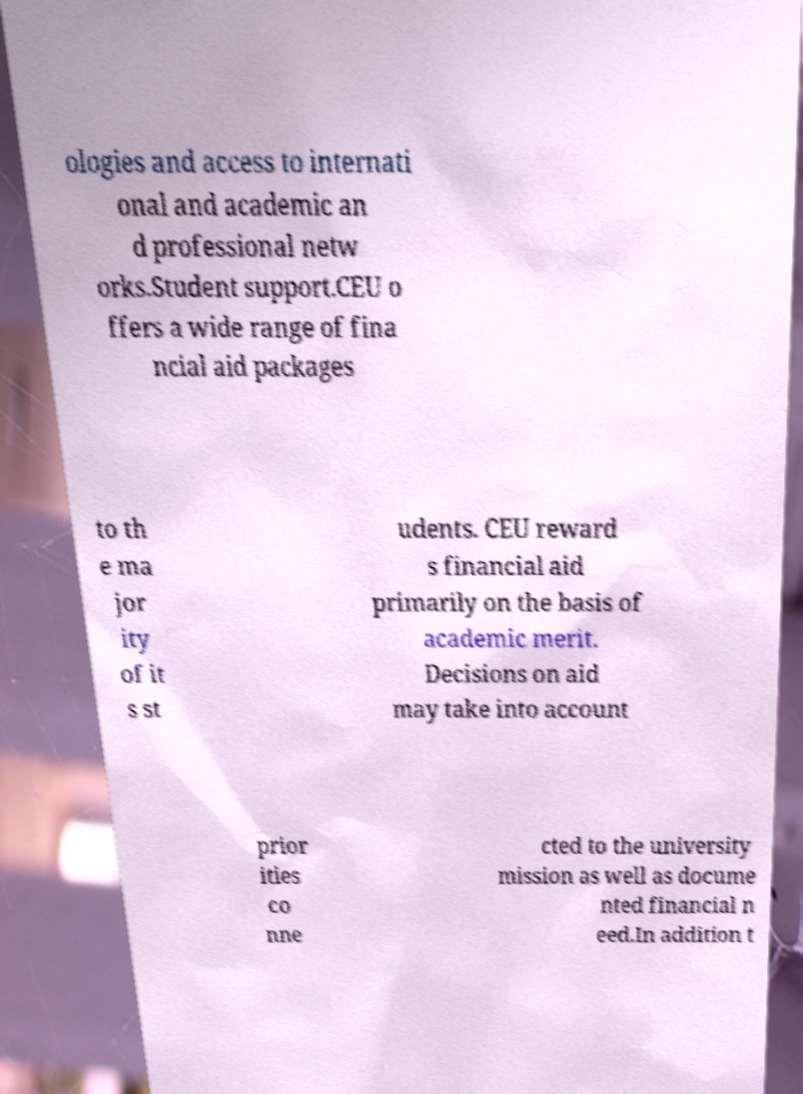For documentation purposes, I need the text within this image transcribed. Could you provide that? ologies and access to internati onal and academic an d professional netw orks.Student support.CEU o ffers a wide range of fina ncial aid packages to th e ma jor ity of it s st udents. CEU reward s financial aid primarily on the basis of academic merit. Decisions on aid may take into account prior ities co nne cted to the university mission as well as docume nted financial n eed.In addition t 